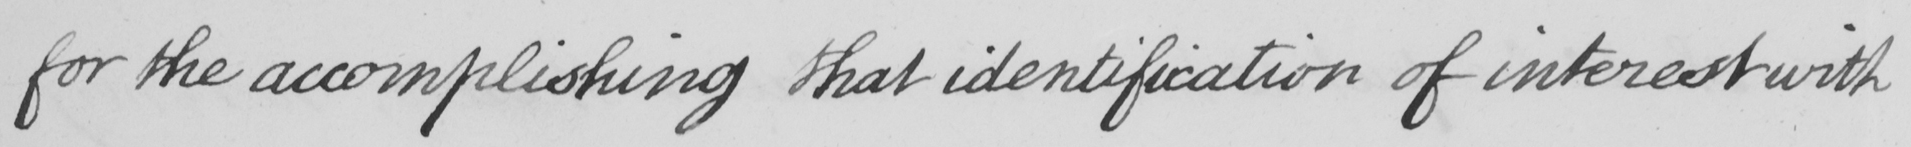Can you tell me what this handwritten text says? for the accomplishing that identification of interest with 